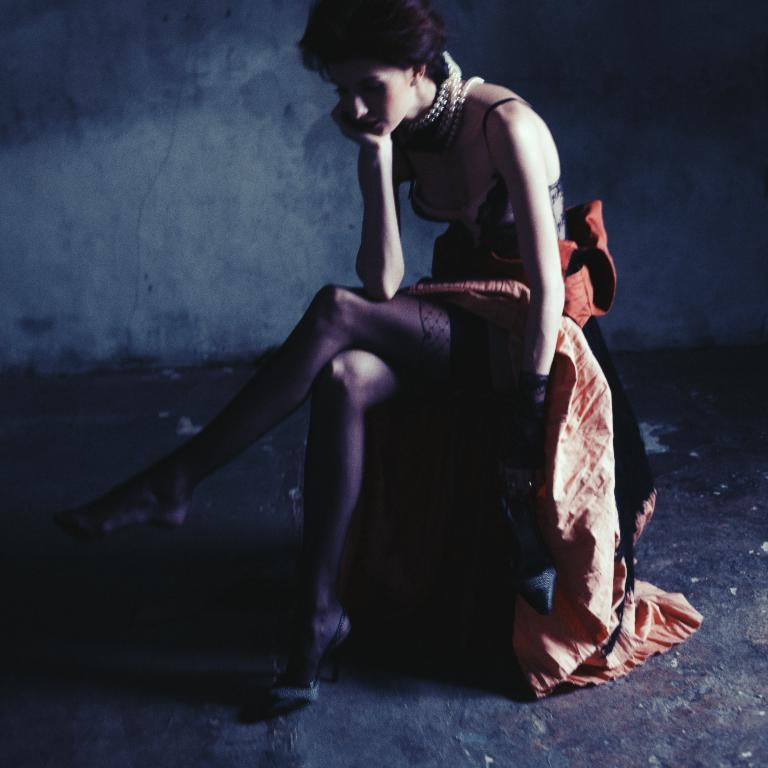Who is the main subject in the image? There is a woman in the image. What is the woman wearing? The woman is wearing a black dress. What is the woman doing in the image? The woman is sitting on a chair. What can be seen in the background of the image? There is a wall in the background of the image. How many rings can be seen on the woman's fingers in the image? There is no mention of rings in the provided facts, so we cannot determine the number of rings on the woman's fingers. What type of sky is visible in the image? The provided facts do not mention the sky, so we cannot determine the type of sky visible in the image. 